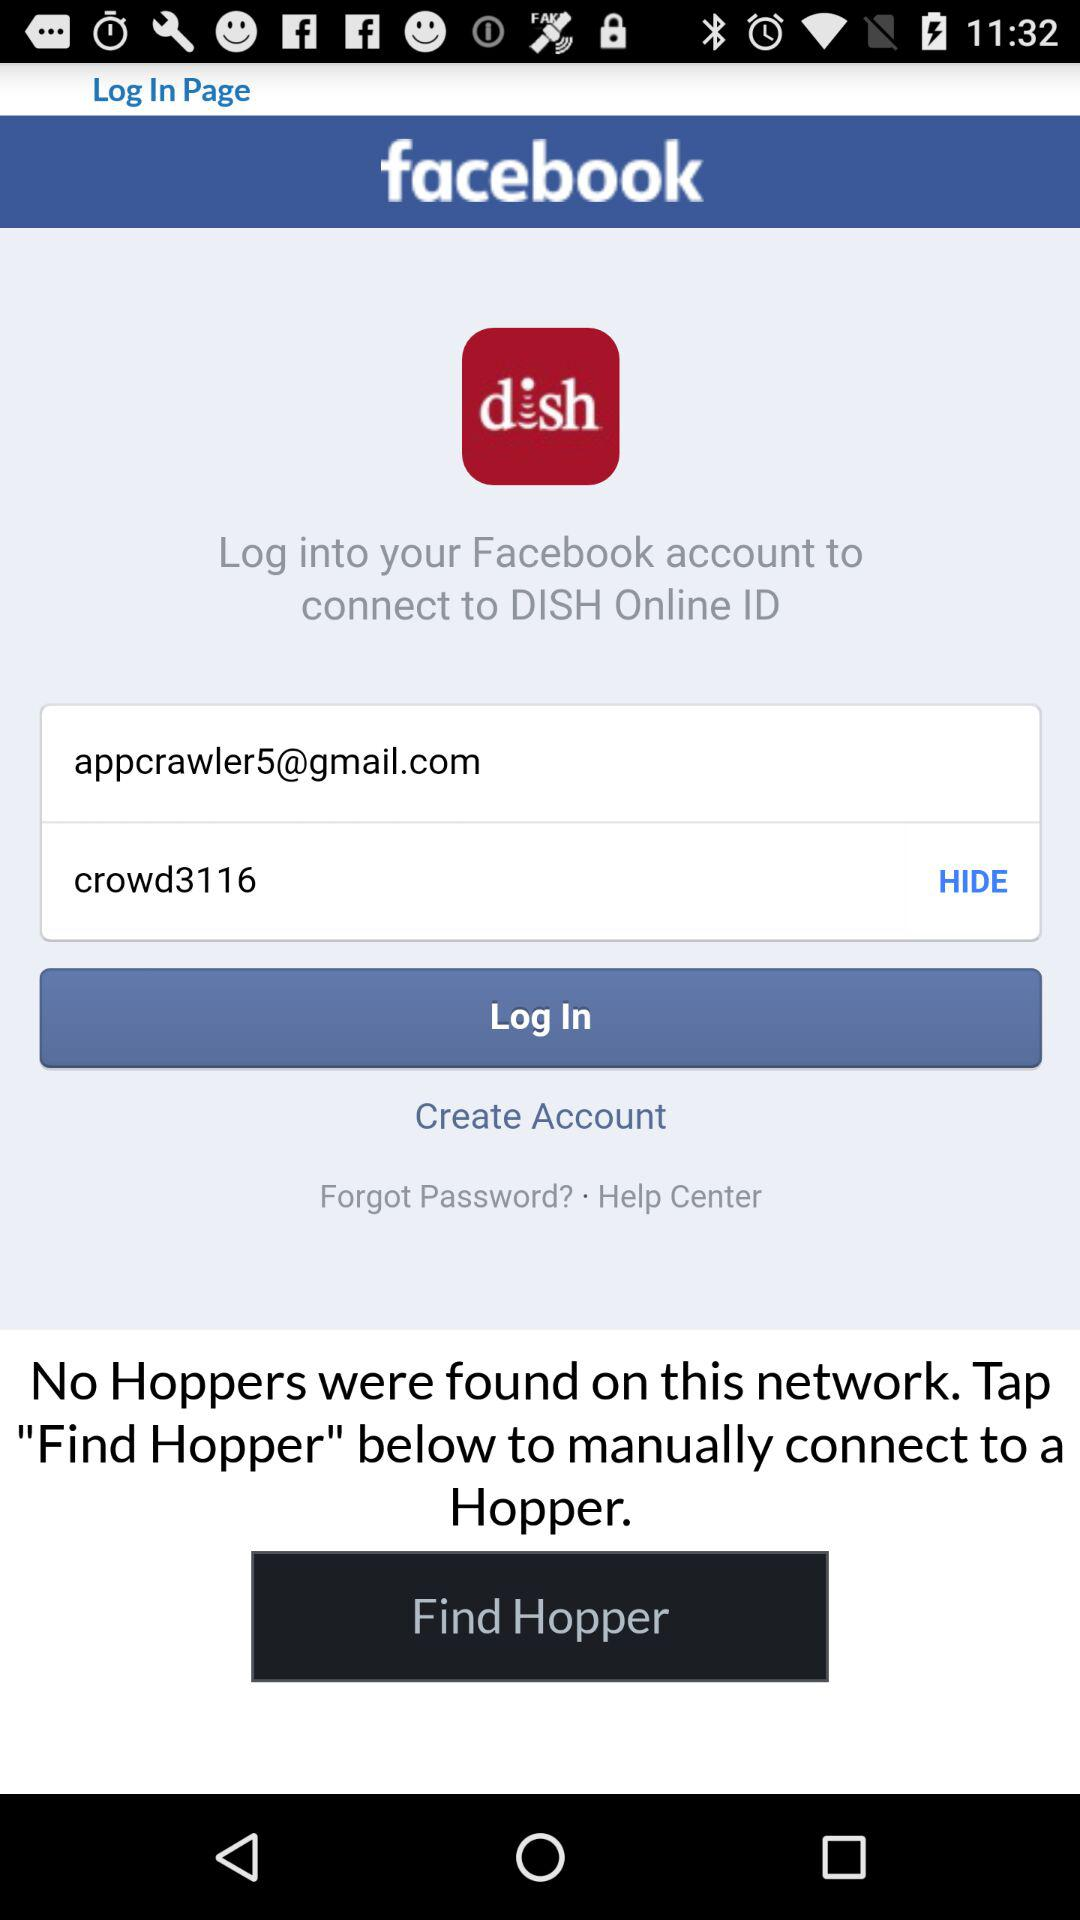What is the email address of the user? The email address of the user is appcrawler5@gmail.com. 